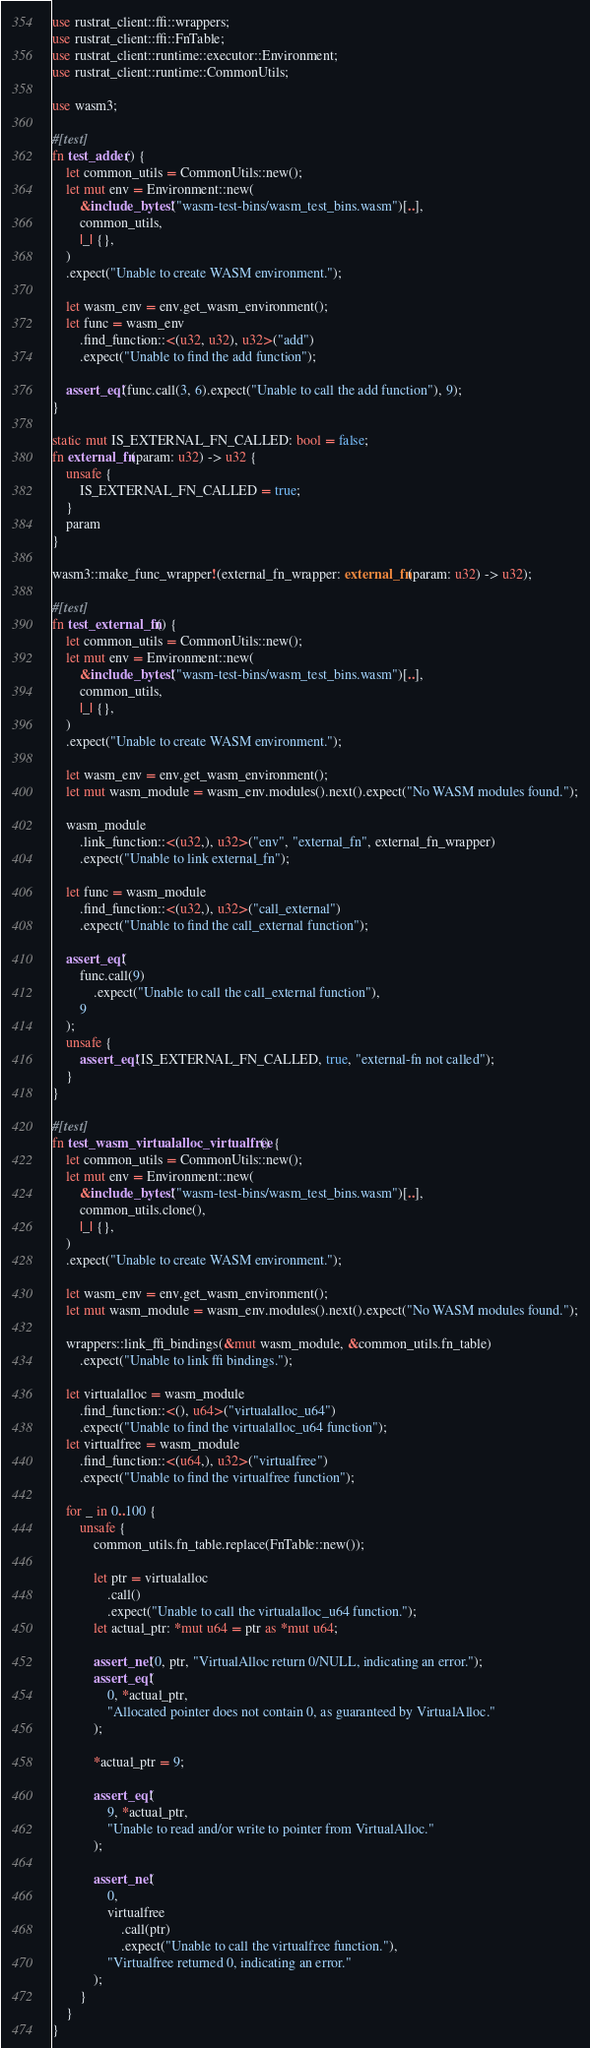Convert code to text. <code><loc_0><loc_0><loc_500><loc_500><_Rust_>use rustrat_client::ffi::wrappers;
use rustrat_client::ffi::FnTable;
use rustrat_client::runtime::executor::Environment;
use rustrat_client::runtime::CommonUtils;

use wasm3;

#[test]
fn test_adder() {
    let common_utils = CommonUtils::new();
    let mut env = Environment::new(
        &include_bytes!("wasm-test-bins/wasm_test_bins.wasm")[..],
        common_utils,
        |_| {},
    )
    .expect("Unable to create WASM environment.");

    let wasm_env = env.get_wasm_environment();
    let func = wasm_env
        .find_function::<(u32, u32), u32>("add")
        .expect("Unable to find the add function");

    assert_eq!(func.call(3, 6).expect("Unable to call the add function"), 9);
}

static mut IS_EXTERNAL_FN_CALLED: bool = false;
fn external_fn(param: u32) -> u32 {
    unsafe {
        IS_EXTERNAL_FN_CALLED = true;
    }
    param
}

wasm3::make_func_wrapper!(external_fn_wrapper: external_fn(param: u32) -> u32);

#[test]
fn test_external_fn() {
    let common_utils = CommonUtils::new();
    let mut env = Environment::new(
        &include_bytes!("wasm-test-bins/wasm_test_bins.wasm")[..],
        common_utils,
        |_| {},
    )
    .expect("Unable to create WASM environment.");

    let wasm_env = env.get_wasm_environment();
    let mut wasm_module = wasm_env.modules().next().expect("No WASM modules found.");

    wasm_module
        .link_function::<(u32,), u32>("env", "external_fn", external_fn_wrapper)
        .expect("Unable to link external_fn");

    let func = wasm_module
        .find_function::<(u32,), u32>("call_external")
        .expect("Unable to find the call_external function");

    assert_eq!(
        func.call(9)
            .expect("Unable to call the call_external function"),
        9
    );
    unsafe {
        assert_eq!(IS_EXTERNAL_FN_CALLED, true, "external-fn not called");
    }
}

#[test]
fn test_wasm_virtualalloc_virtualfree() {
    let common_utils = CommonUtils::new();
    let mut env = Environment::new(
        &include_bytes!("wasm-test-bins/wasm_test_bins.wasm")[..],
        common_utils.clone(),
        |_| {},
    )
    .expect("Unable to create WASM environment.");

    let wasm_env = env.get_wasm_environment();
    let mut wasm_module = wasm_env.modules().next().expect("No WASM modules found.");

    wrappers::link_ffi_bindings(&mut wasm_module, &common_utils.fn_table)
        .expect("Unable to link ffi bindings.");

    let virtualalloc = wasm_module
        .find_function::<(), u64>("virtualalloc_u64")
        .expect("Unable to find the virtualalloc_u64 function");
    let virtualfree = wasm_module
        .find_function::<(u64,), u32>("virtualfree")
        .expect("Unable to find the virtualfree function");

    for _ in 0..100 {
        unsafe {
            common_utils.fn_table.replace(FnTable::new());

            let ptr = virtualalloc
                .call()
                .expect("Unable to call the virtualalloc_u64 function.");
            let actual_ptr: *mut u64 = ptr as *mut u64;

            assert_ne!(0, ptr, "VirtualAlloc return 0/NULL, indicating an error.");
            assert_eq!(
                0, *actual_ptr,
                "Allocated pointer does not contain 0, as guaranteed by VirtualAlloc."
            );

            *actual_ptr = 9;

            assert_eq!(
                9, *actual_ptr,
                "Unable to read and/or write to pointer from VirtualAlloc."
            );

            assert_ne!(
                0,
                virtualfree
                    .call(ptr)
                    .expect("Unable to call the virtualfree function."),
                "Virtualfree returned 0, indicating an error."
            );
        }
    }
}
</code> 